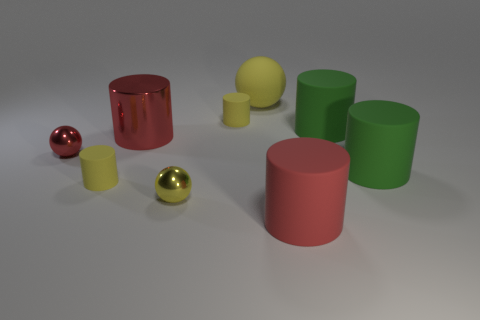Subtract all yellow cylinders. How many cylinders are left? 4 Subtract all red matte cylinders. How many cylinders are left? 5 Add 1 large cylinders. How many objects exist? 10 Subtract all gray cylinders. Subtract all cyan spheres. How many cylinders are left? 6 Subtract all balls. How many objects are left? 6 Subtract 0 gray cylinders. How many objects are left? 9 Subtract all small red metallic balls. Subtract all green matte objects. How many objects are left? 6 Add 1 large rubber things. How many large rubber things are left? 5 Add 7 small yellow metallic objects. How many small yellow metallic objects exist? 8 